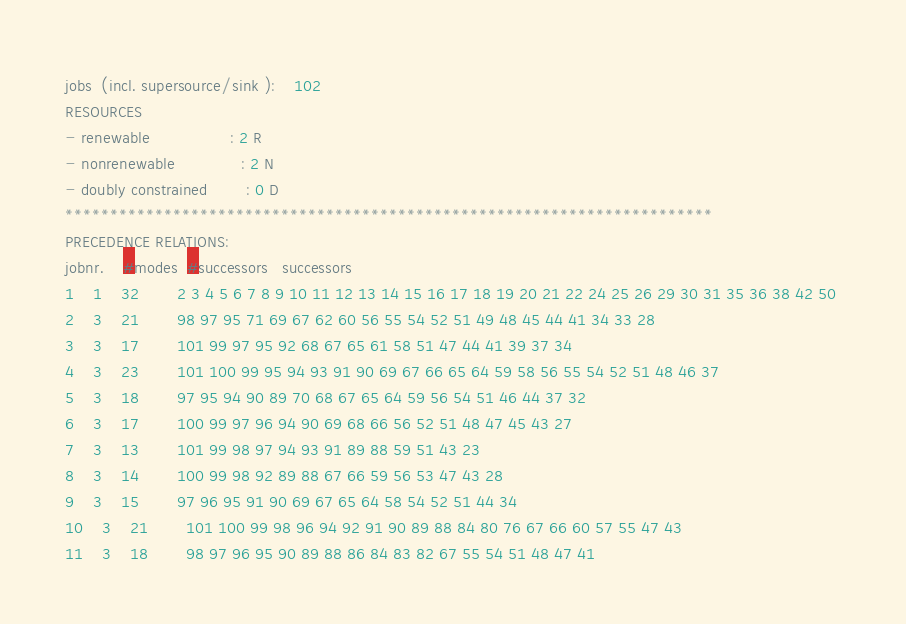Convert code to text. <code><loc_0><loc_0><loc_500><loc_500><_ObjectiveC_>jobs  (incl. supersource/sink ):	102
RESOURCES
- renewable                 : 2 R
- nonrenewable              : 2 N
- doubly constrained        : 0 D
************************************************************************
PRECEDENCE RELATIONS:
jobnr.    #modes  #successors   successors
1	1	32		2 3 4 5 6 7 8 9 10 11 12 13 14 15 16 17 18 19 20 21 22 24 25 26 29 30 31 35 36 38 42 50 
2	3	21		98 97 95 71 69 67 62 60 56 55 54 52 51 49 48 45 44 41 34 33 28 
3	3	17		101 99 97 95 92 68 67 65 61 58 51 47 44 41 39 37 34 
4	3	23		101 100 99 95 94 93 91 90 69 67 66 65 64 59 58 56 55 54 52 51 48 46 37 
5	3	18		97 95 94 90 89 70 68 67 65 64 59 56 54 51 46 44 37 32 
6	3	17		100 99 97 96 94 90 69 68 66 56 52 51 48 47 45 43 27 
7	3	13		101 99 98 97 94 93 91 89 88 59 51 43 23 
8	3	14		100 99 98 92 89 88 67 66 59 56 53 47 43 28 
9	3	15		97 96 95 91 90 69 67 65 64 58 54 52 51 44 34 
10	3	21		101 100 99 98 96 94 92 91 90 89 88 84 80 76 67 66 60 57 55 47 43 
11	3	18		98 97 96 95 90 89 88 86 84 83 82 67 55 54 51 48 47 41 </code> 